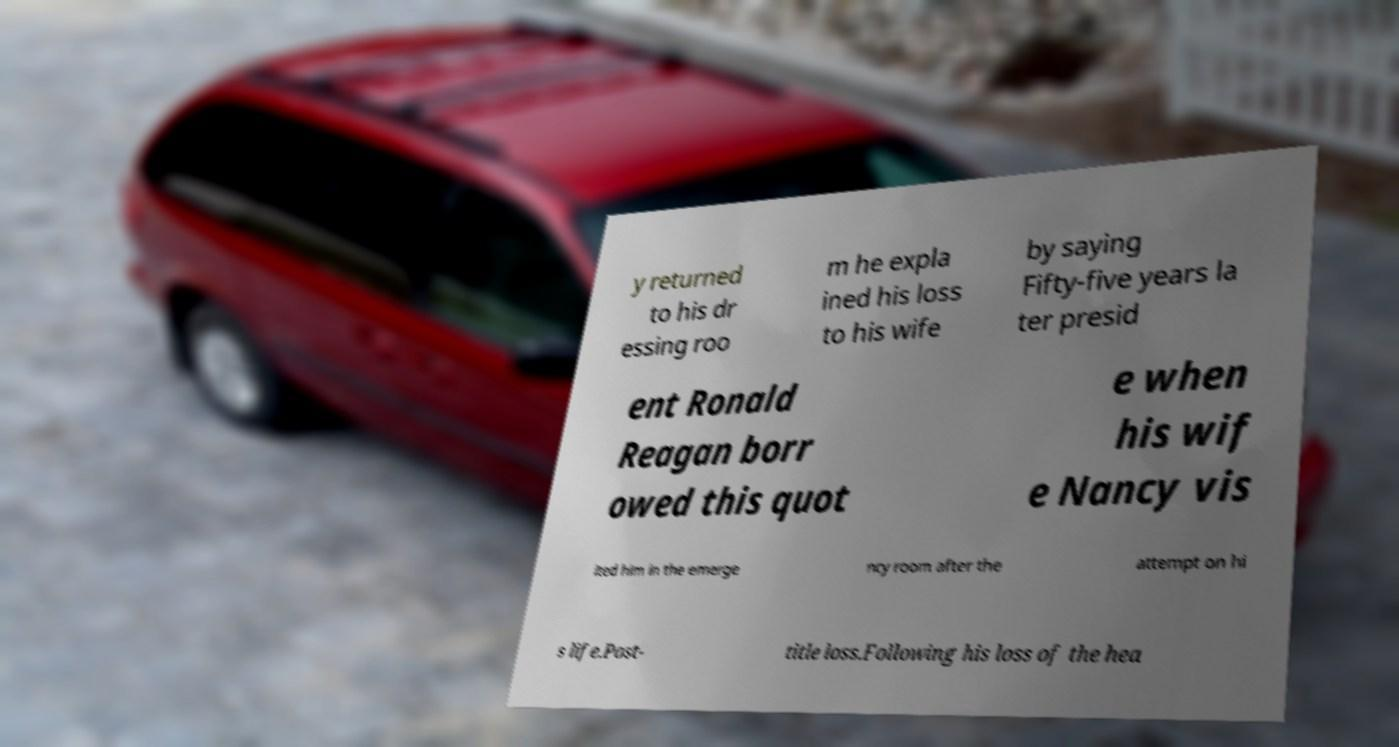Can you read and provide the text displayed in the image?This photo seems to have some interesting text. Can you extract and type it out for me? y returned to his dr essing roo m he expla ined his loss to his wife by saying Fifty-five years la ter presid ent Ronald Reagan borr owed this quot e when his wif e Nancy vis ited him in the emerge ncy room after the attempt on hi s life.Post- title loss.Following his loss of the hea 